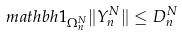<formula> <loc_0><loc_0><loc_500><loc_500>\ m a t h b h { 1 } _ { \Omega _ { n } ^ { N } } \| Y _ { n } ^ { N } \| \leq D _ { n } ^ { N }</formula> 